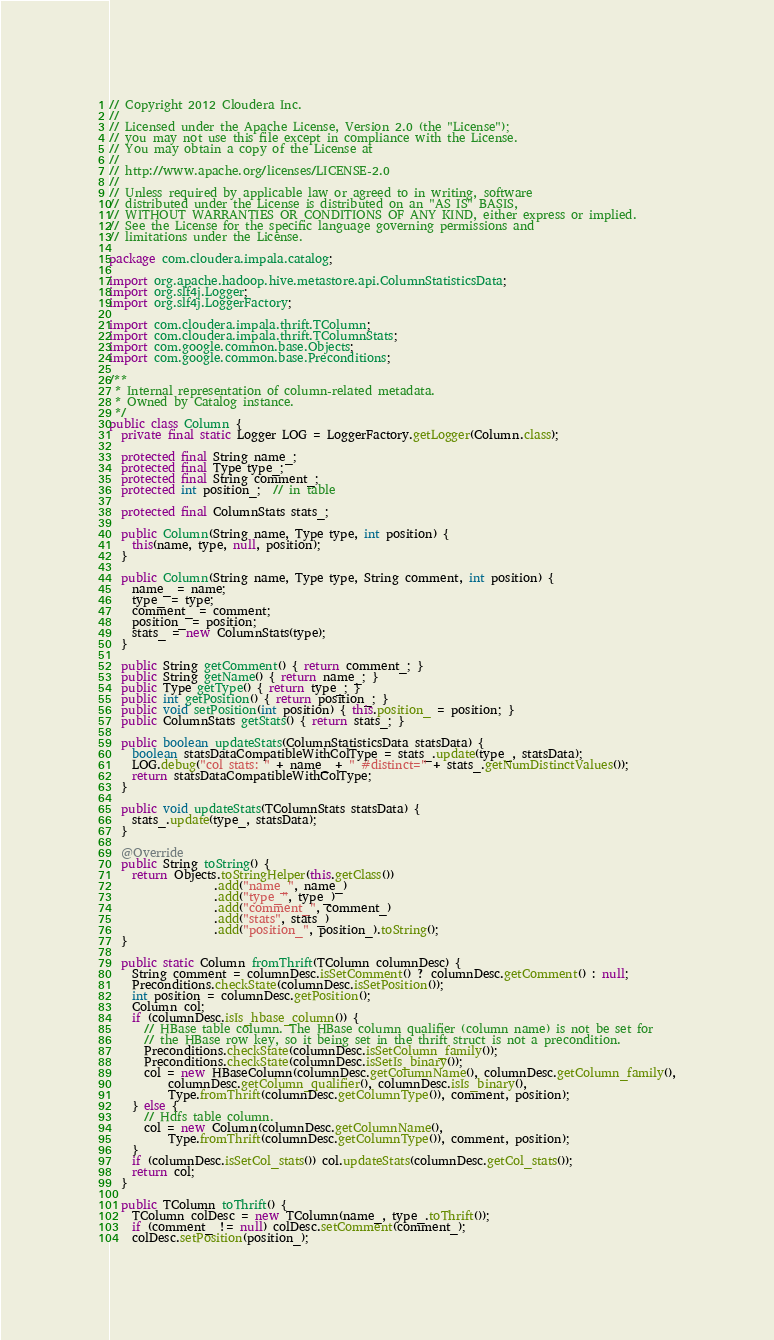<code> <loc_0><loc_0><loc_500><loc_500><_Java_>// Copyright 2012 Cloudera Inc.
//
// Licensed under the Apache License, Version 2.0 (the "License");
// you may not use this file except in compliance with the License.
// You may obtain a copy of the License at
//
// http://www.apache.org/licenses/LICENSE-2.0
//
// Unless required by applicable law or agreed to in writing, software
// distributed under the License is distributed on an "AS IS" BASIS,
// WITHOUT WARRANTIES OR CONDITIONS OF ANY KIND, either express or implied.
// See the License for the specific language governing permissions and
// limitations under the License.

package com.cloudera.impala.catalog;

import org.apache.hadoop.hive.metastore.api.ColumnStatisticsData;
import org.slf4j.Logger;
import org.slf4j.LoggerFactory;

import com.cloudera.impala.thrift.TColumn;
import com.cloudera.impala.thrift.TColumnStats;
import com.google.common.base.Objects;
import com.google.common.base.Preconditions;

/**
 * Internal representation of column-related metadata.
 * Owned by Catalog instance.
 */
public class Column {
  private final static Logger LOG = LoggerFactory.getLogger(Column.class);

  protected final String name_;
  protected final Type type_;
  protected final String comment_;
  protected int position_;  // in table

  protected final ColumnStats stats_;

  public Column(String name, Type type, int position) {
    this(name, type, null, position);
  }

  public Column(String name, Type type, String comment, int position) {
    name_ = name;
    type_ = type;
    comment_ = comment;
    position_ = position;
    stats_ = new ColumnStats(type);
  }

  public String getComment() { return comment_; }
  public String getName() { return name_; }
  public Type getType() { return type_; }
  public int getPosition() { return position_; }
  public void setPosition(int position) { this.position_ = position; }
  public ColumnStats getStats() { return stats_; }

  public boolean updateStats(ColumnStatisticsData statsData) {
    boolean statsDataCompatibleWithColType = stats_.update(type_, statsData);
    LOG.debug("col stats: " + name_ + " #distinct=" + stats_.getNumDistinctValues());
    return statsDataCompatibleWithColType;
  }

  public void updateStats(TColumnStats statsData) {
    stats_.update(type_, statsData);
  }

  @Override
  public String toString() {
    return Objects.toStringHelper(this.getClass())
                  .add("name_", name_)
                  .add("type_", type_)
                  .add("comment_", comment_)
                  .add("stats", stats_)
                  .add("position_", position_).toString();
  }

  public static Column fromThrift(TColumn columnDesc) {
    String comment = columnDesc.isSetComment() ? columnDesc.getComment() : null;
    Preconditions.checkState(columnDesc.isSetPosition());
    int position = columnDesc.getPosition();
    Column col;
    if (columnDesc.isIs_hbase_column()) {
      // HBase table column. The HBase column qualifier (column name) is not be set for
      // the HBase row key, so it being set in the thrift struct is not a precondition.
      Preconditions.checkState(columnDesc.isSetColumn_family());
      Preconditions.checkState(columnDesc.isSetIs_binary());
      col = new HBaseColumn(columnDesc.getColumnName(), columnDesc.getColumn_family(),
          columnDesc.getColumn_qualifier(), columnDesc.isIs_binary(),
          Type.fromThrift(columnDesc.getColumnType()), comment, position);
    } else {
      // Hdfs table column.
      col = new Column(columnDesc.getColumnName(),
          Type.fromThrift(columnDesc.getColumnType()), comment, position);
    }
    if (columnDesc.isSetCol_stats()) col.updateStats(columnDesc.getCol_stats());
    return col;
  }

  public TColumn toThrift() {
    TColumn colDesc = new TColumn(name_, type_.toThrift());
    if (comment_ != null) colDesc.setComment(comment_);
    colDesc.setPosition(position_);</code> 